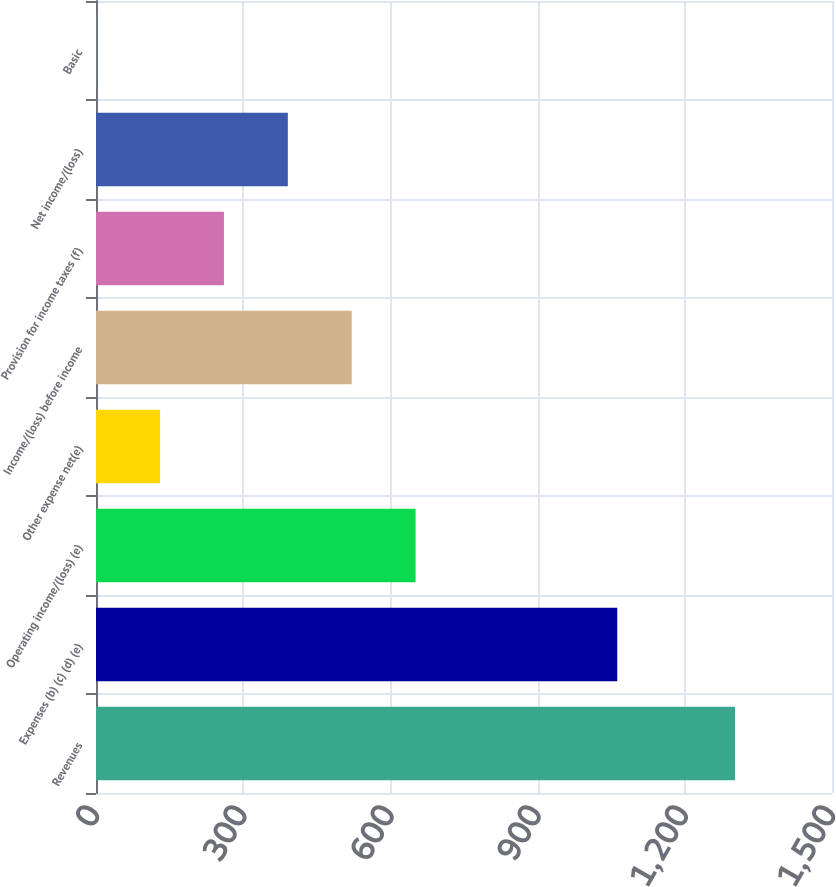Convert chart to OTSL. <chart><loc_0><loc_0><loc_500><loc_500><bar_chart><fcel>Revenues<fcel>Expenses (b) (c) (d) (e)<fcel>Operating income/(loss) (e)<fcel>Other expense net(e)<fcel>Income/(loss) before income<fcel>Provision for income taxes (f)<fcel>Net income/(loss)<fcel>Basic<nl><fcel>1302.4<fcel>1062.3<fcel>651.39<fcel>130.55<fcel>521.18<fcel>260.76<fcel>390.97<fcel>0.34<nl></chart> 